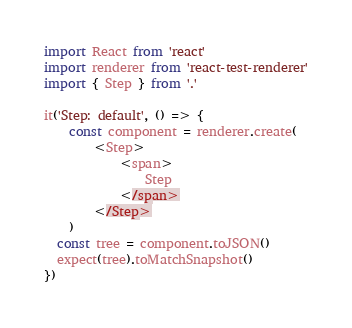<code> <loc_0><loc_0><loc_500><loc_500><_JavaScript_>import React from 'react'
import renderer from 'react-test-renderer'
import { Step } from '.'

it('Step: default', () => {
    const component = renderer.create(
        <Step>
            <span>
                Step
            </span>
        </Step>
    )
  const tree = component.toJSON()
  expect(tree).toMatchSnapshot()
})
</code> 